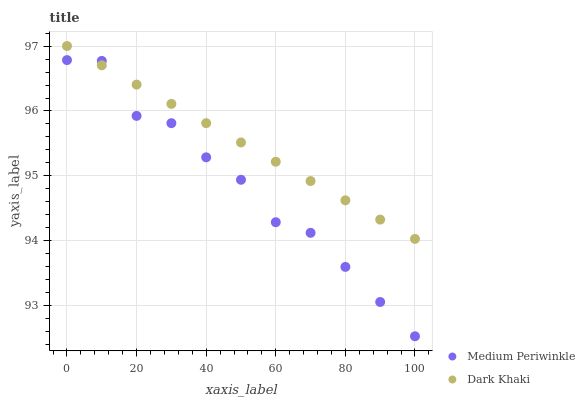Does Medium Periwinkle have the minimum area under the curve?
Answer yes or no. Yes. Does Dark Khaki have the maximum area under the curve?
Answer yes or no. Yes. Does Medium Periwinkle have the maximum area under the curve?
Answer yes or no. No. Is Dark Khaki the smoothest?
Answer yes or no. Yes. Is Medium Periwinkle the roughest?
Answer yes or no. Yes. Is Medium Periwinkle the smoothest?
Answer yes or no. No. Does Medium Periwinkle have the lowest value?
Answer yes or no. Yes. Does Dark Khaki have the highest value?
Answer yes or no. Yes. Does Medium Periwinkle have the highest value?
Answer yes or no. No. Does Medium Periwinkle intersect Dark Khaki?
Answer yes or no. Yes. Is Medium Periwinkle less than Dark Khaki?
Answer yes or no. No. Is Medium Periwinkle greater than Dark Khaki?
Answer yes or no. No. 